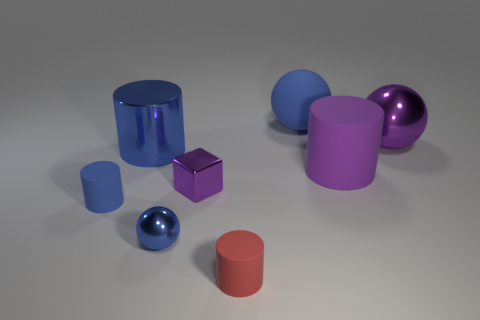Do the matte cylinder left of the tiny purple metal block and the metal sphere behind the tiny blue rubber cylinder have the same color?
Offer a terse response. No. What is the shape of the metallic object that is the same color as the tiny shiny ball?
Offer a terse response. Cylinder. What number of metallic objects are either tiny cyan balls or big blue balls?
Provide a succinct answer. 0. The shiny ball that is on the right side of the small object on the right side of the small metal thing that is right of the blue shiny ball is what color?
Offer a very short reply. Purple. What is the color of the big rubber thing that is the same shape as the tiny blue shiny thing?
Offer a very short reply. Blue. Is there anything else of the same color as the small metallic sphere?
Your response must be concise. Yes. What number of other objects are the same material as the purple block?
Provide a succinct answer. 3. How big is the block?
Keep it short and to the point. Small. Is there another purple rubber thing of the same shape as the big purple matte object?
Give a very brief answer. No. What number of objects are either gray metallic blocks or rubber things to the left of the small shiny ball?
Your answer should be very brief. 1. 